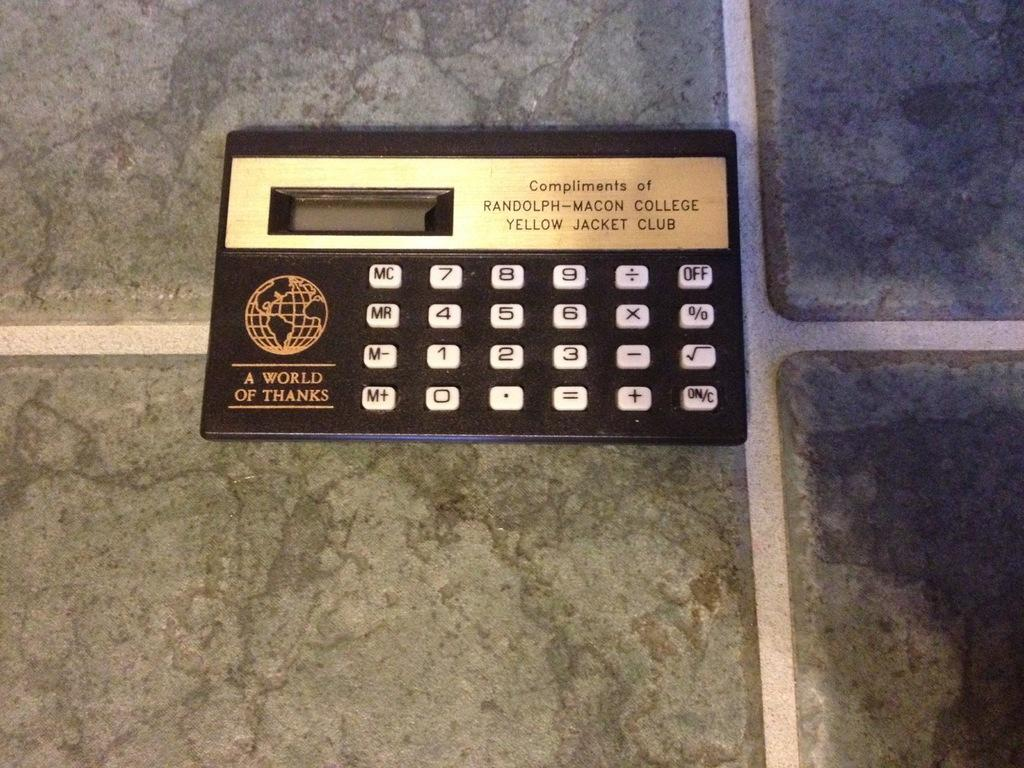What object is visible in the image? There is a calculator in the image. Where is the calculator located? The calculator is placed on a table. What type of quilt is draped over the deer in the image? There is no quilt or deer present in the image; it only features a calculator placed on a table. 